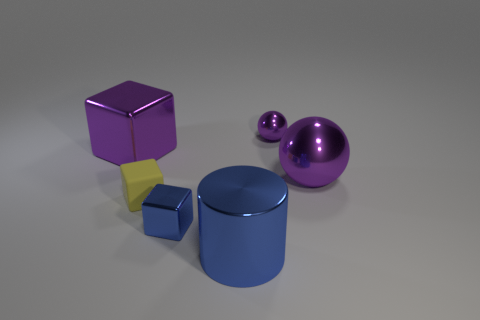There is a yellow cube on the left side of the blue block; what material is it?
Your response must be concise. Rubber. What number of objects are either cubes in front of the yellow cube or big purple shiny things that are to the right of the tiny yellow rubber block?
Your answer should be very brief. 2. There is a big object that is the same shape as the small blue object; what is it made of?
Offer a very short reply. Metal. Is the color of the large shiny thing that is to the left of the metallic cylinder the same as the large shiny ball behind the yellow matte block?
Your answer should be compact. Yes. Are there any purple things of the same size as the purple block?
Make the answer very short. Yes. What material is the small object that is both behind the tiny metal cube and in front of the purple metallic cube?
Give a very brief answer. Rubber. How many shiny objects are either yellow things or large yellow spheres?
Provide a short and direct response. 0. There is a tiny thing that is the same material as the tiny purple ball; what is its shape?
Offer a very short reply. Cube. How many objects are behind the purple metal cube and to the left of the yellow rubber object?
Make the answer very short. 0. Is there anything else that has the same shape as the large blue object?
Provide a succinct answer. No. 